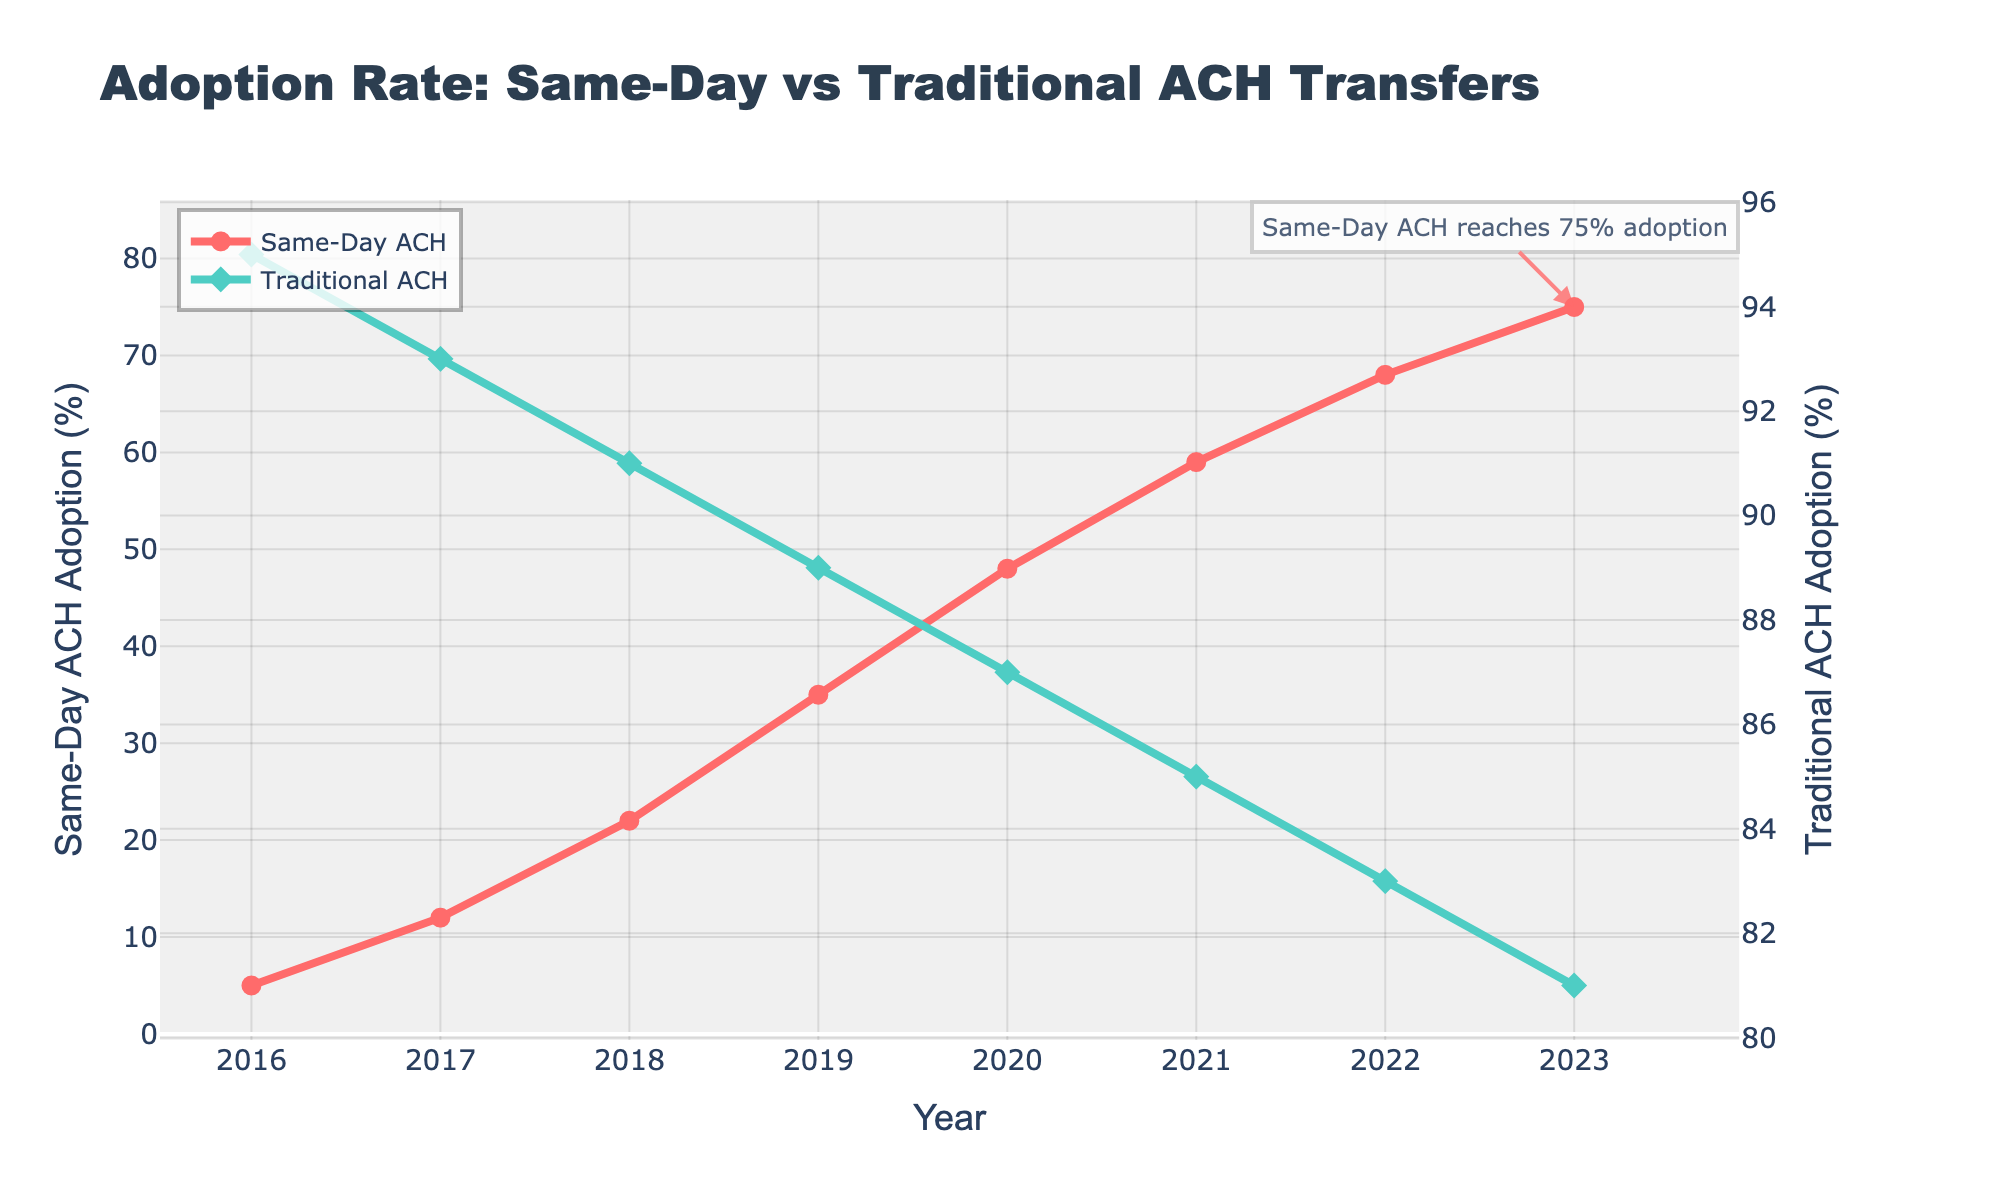What trend do you observe for the adoption rates of Same-Day ACH from 2016 to 2023? The adoption rate of Same-Day ACH has been consistently increasing every year from 5% in 2016 to 75% in 2023.
Answer: Increasing trend What trend do you observe for the adoption rates of Traditional ACH from 2016 to 2023? The adoption rate of Traditional ACH has been consistently decreasing every year from 95% in 2016 to 81% in 2023.
Answer: Decreasing trend In which year did Same-Day ACH adoption surpass 50%? The data indicates Same-Day ACH adoption surpassed 50% in the year 2021 when it reached 59%.
Answer: 2021 How much did the adoption rate of Same-Day ACH increase from 2016 to 2023? To find the increase, subtract the adoption rate in 2016 from the adoption rate in 2023: 75% - 5% = 70%.
Answer: 70% What is the difference in adoption rates between Same-Day ACH and Traditional ACH in 2023? To find the difference, subtract the adoption rate of Traditional ACH from Same-Day ACH in 2023: 75% - 81% = -6%.
Answer: -6% When was the largest single-year increase in Same-Day ACH adoption observed? By inspecting the data, the largest increase occurred between 2018 and 2019, where the adoption rate rose from 22% to 35%, a 13% increase.
Answer: 2018 to 2019 Compare the relative changes in adoption rates of Same-Day ACH and Traditional ACH from 2020 to 2021. From 2020 to 2021, Same-Day ACH adoption increased by 11% (48% to 59%), while Traditional ACH adoption decreased by 2% (87% to 85%).
Answer: Same-Day ACH increased by 11%, Traditional ACH decreased by 2% What color represents Same-Day ACH in the plot and how can you identify it? Same-Day ACH is represented by a red line with circle markers, as noted in the legend and color coding of the traces.
Answer: Red Between 2019 and 2022, did the adoption rate of Traditional ACH ever fall below the adoption rate of Same-Day ACH? No, despite the decreasing trend of Traditional ACH and the increasing trend of Same-Day ACH, Traditional ACH remains higher than Same-Day ACH from 2019 to 2022.
Answer: No 